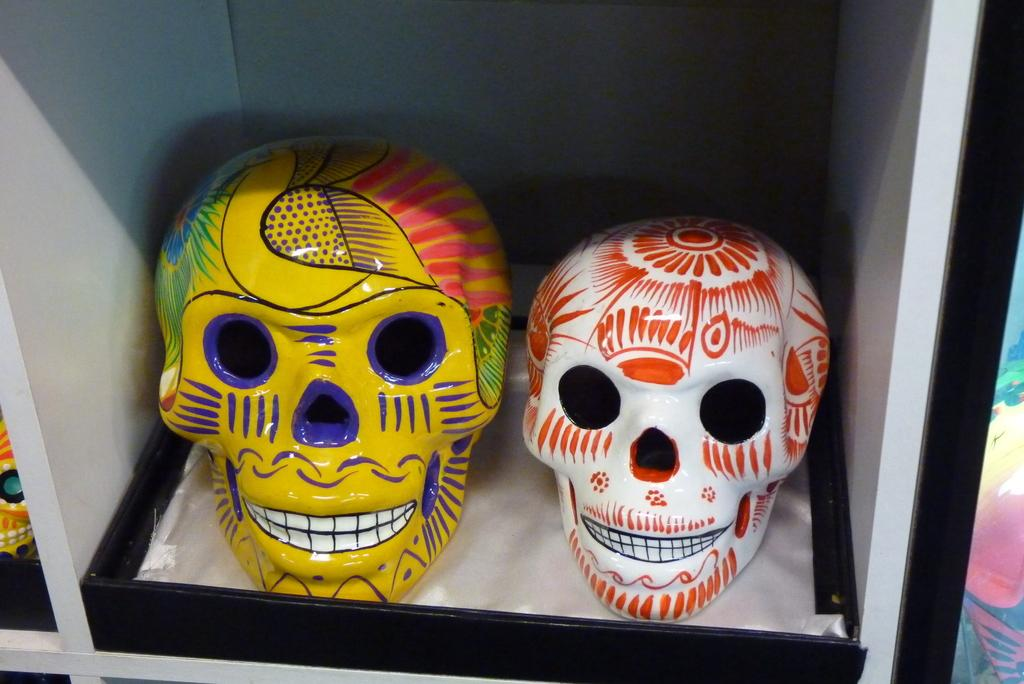What type of objects are present in the image? There are decorated face skeletons in the image. How are the skeletons stored or displayed? The skeletons are kept in a box. What type of coil is used to heat the comb in the image? There is no coil or comb present in the image; it features decorated face skeletons kept in a box. 